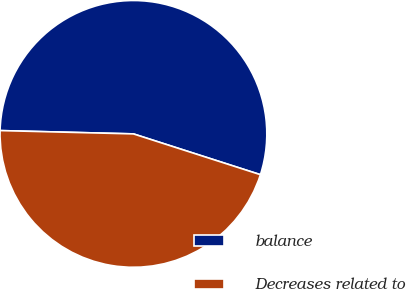<chart> <loc_0><loc_0><loc_500><loc_500><pie_chart><fcel>balance<fcel>Decreases related to<nl><fcel>54.55%<fcel>45.45%<nl></chart> 